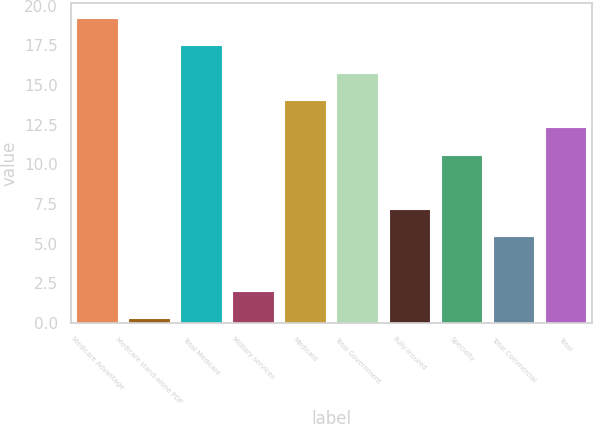Convert chart. <chart><loc_0><loc_0><loc_500><loc_500><bar_chart><fcel>Medicare Advantage<fcel>Medicare stand-alone PDP<fcel>Total Medicare<fcel>Military services<fcel>Medicaid<fcel>Total Government<fcel>Fully-insured<fcel>Specialty<fcel>Total Commercial<fcel>Total<nl><fcel>19.22<fcel>0.3<fcel>17.5<fcel>2.02<fcel>14.06<fcel>15.78<fcel>7.18<fcel>10.62<fcel>5.46<fcel>12.34<nl></chart> 